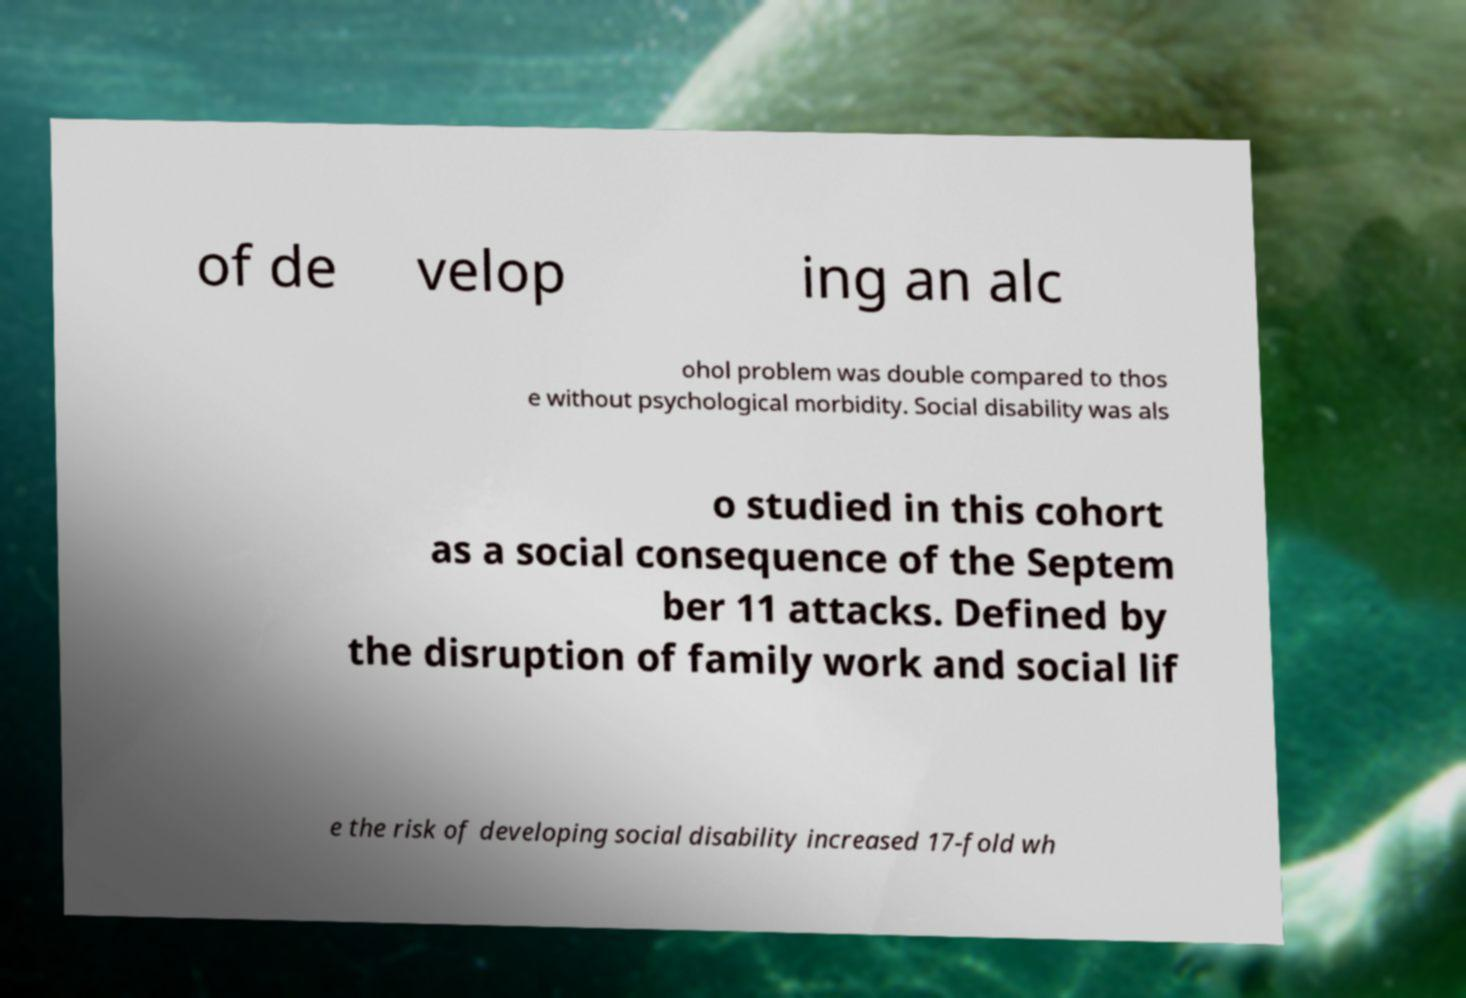Please identify and transcribe the text found in this image. of de velop ing an alc ohol problem was double compared to thos e without psychological morbidity. Social disability was als o studied in this cohort as a social consequence of the Septem ber 11 attacks. Defined by the disruption of family work and social lif e the risk of developing social disability increased 17-fold wh 